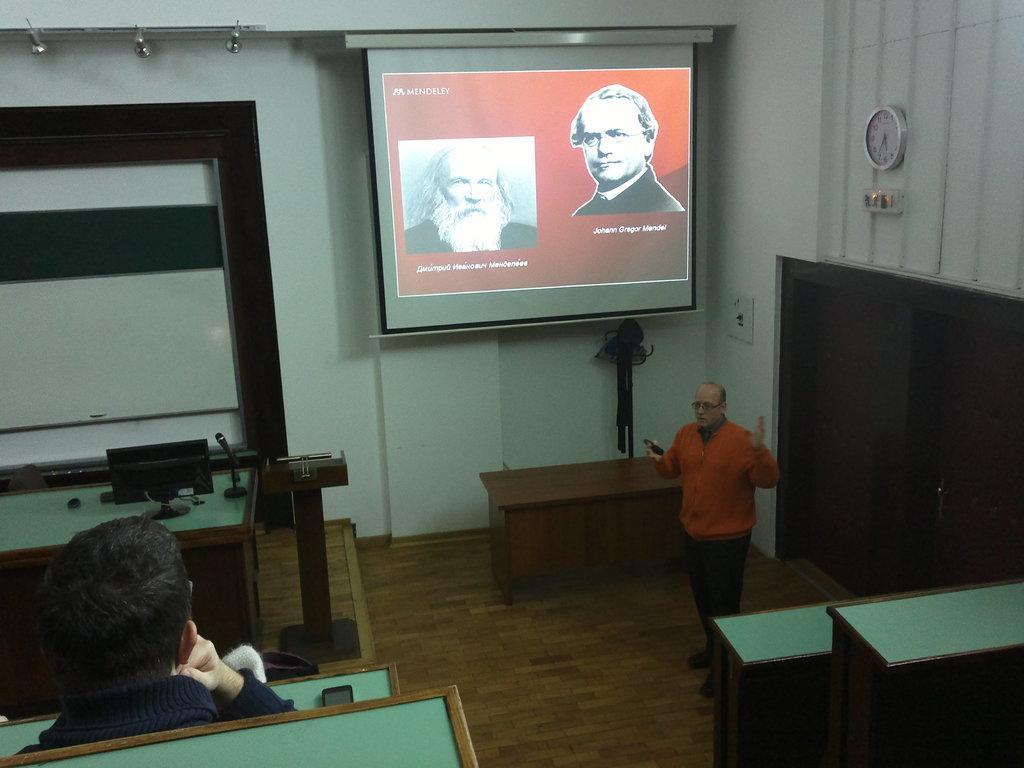Could you give a brief overview of what you see in this image? this picture is taken inside a classroom. The man standing wore a orange shirt is explaining. And there is a other person sitting on the bench. There is a table to the left and a podium beside it. On the table there is a monitor and a microphone. There is projector board hung on the wall and images with names are displayed on it. On the right there is door and above it there is a clock. There is another table behind the man standing.  